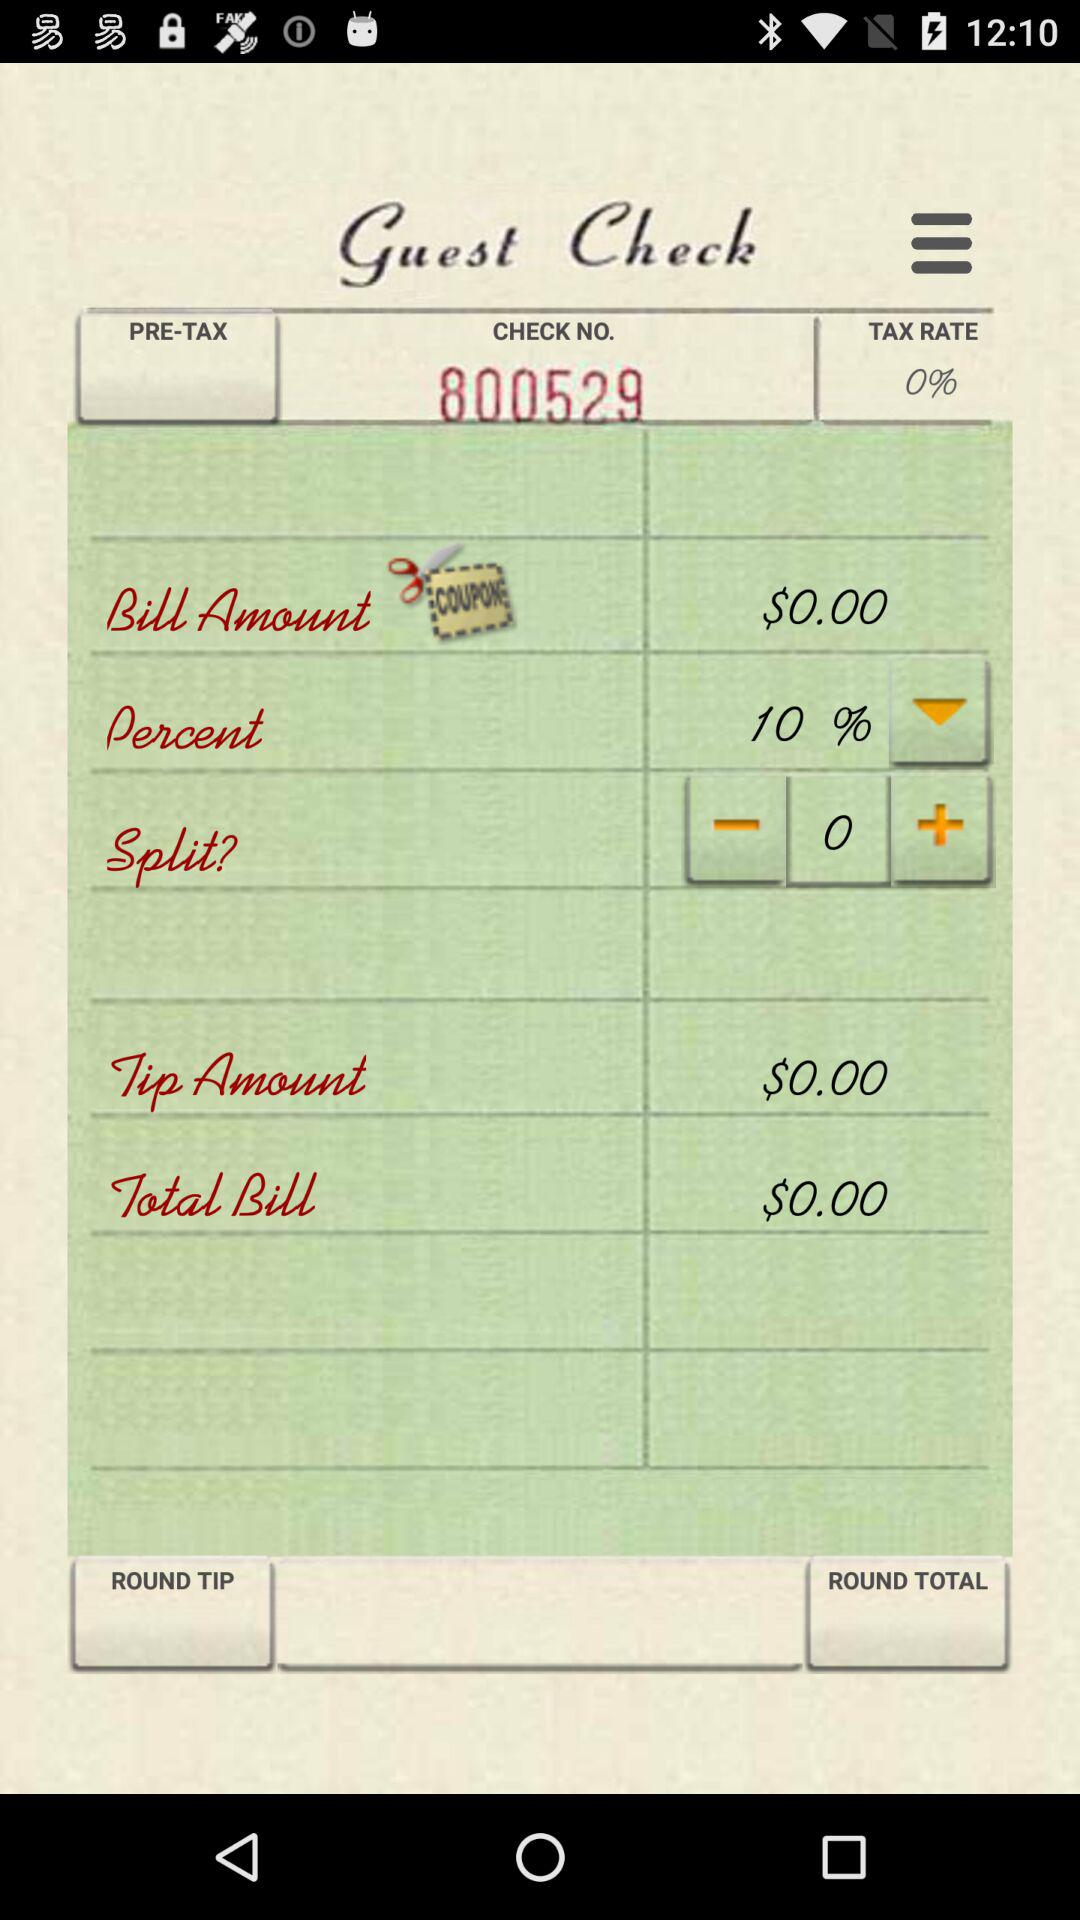What is the total bill? The total bill is $0.00. 